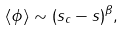<formula> <loc_0><loc_0><loc_500><loc_500>\langle \phi \rangle \sim ( s _ { c } - s ) ^ { \beta } ,</formula> 